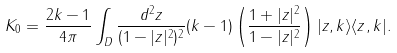Convert formula to latex. <formula><loc_0><loc_0><loc_500><loc_500>K _ { 0 } = \frac { 2 k - 1 } { 4 \pi } \int _ { D } \frac { d ^ { 2 } z } { ( 1 - | z | ^ { 2 } ) ^ { 2 } } ( k - 1 ) \left ( \frac { 1 + | z | ^ { 2 } } { 1 - | z | ^ { 2 } } \right ) | z , k \rangle \langle z , k | .</formula> 